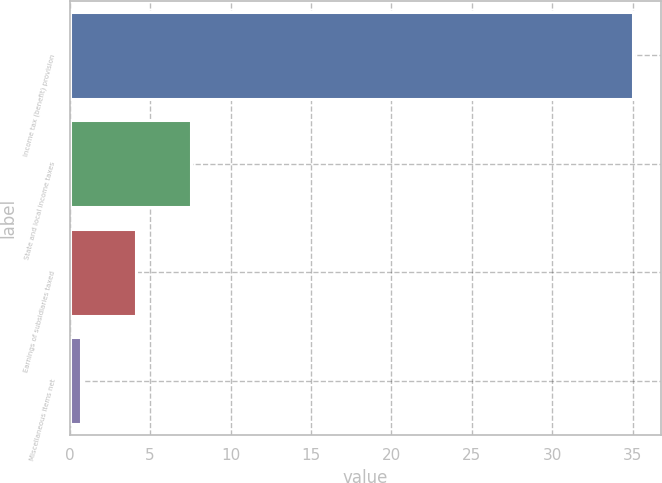<chart> <loc_0><loc_0><loc_500><loc_500><bar_chart><fcel>Income tax (benefit) provision<fcel>State and local income taxes<fcel>Earnings of subsidiaries taxed<fcel>Miscellaneous items net<nl><fcel>35<fcel>7.56<fcel>4.13<fcel>0.7<nl></chart> 